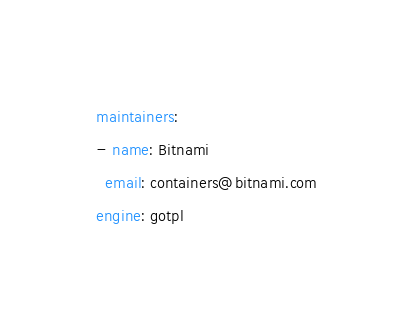Convert code to text. <code><loc_0><loc_0><loc_500><loc_500><_YAML_>maintainers:
- name: Bitnami
  email: containers@bitnami.com
engine: gotpl
</code> 